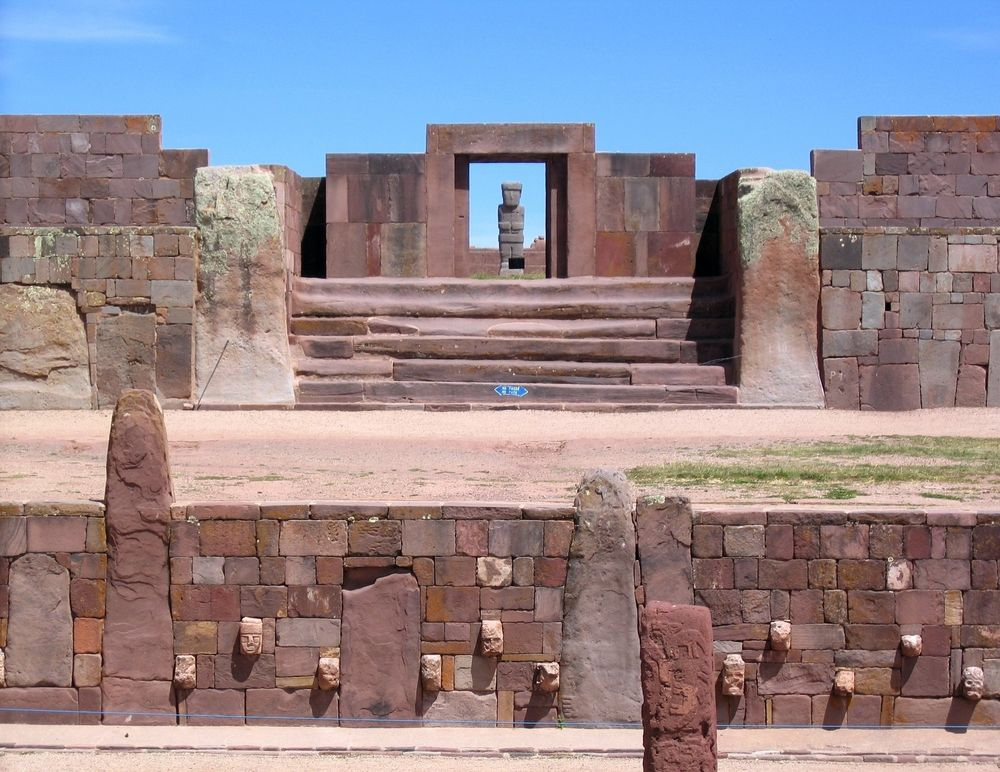If you could time travel to when the Tiwanaku civilization was at its peak, what would be your first impression upon seeing this site? Time traveling to the peak of the Tiwanaku civilization, the first impression upon seeing this site would be one of awe and wonder. The towering stone structures would appear even more majestic in their prime, their intricate carvings and precise engineering unweathered by time. The site would likely be bustling with activity, with artisans skillfully working on stone carvings, priests performing rituals, and traders engaging in lively exchanges. The vibrant colors of textiles and decorations adorning the structures would be a stark contrast against the serene backdrop of the high-altitude Andean plains. The air would be filled with the sounds of human voices, music, and the ever-present wind blowing through the surrounding landscape. The grandeur of the architecture, combined with the palpable sense of a thriving, spiritually rich society, would leave an indelible impression of a sophisticated and culturally dynamic civilization. How might the Tiwanaku people have utilized this structure in their daily lives? The Tiwanaku people likely utilized this structure for a variety of essential functions that intertwined their daily lives with their spiritual and administrative practices. This central edifice could have served as a ceremonial center, where rituals and religious ceremonies were conducted to honor their gods and seek blessings for harvests, health, and prosperity. It may have also played a role in governance, hosting important meetings of leaders and officials for political and social decision-making. The elevated staircase leading to the doorway suggests a sanctified space, potentially used by priests for rituals and as a vantage point for addressing the community. Additionally, the location and impressive architecture of the structure imply its use as a landmark for gatherings, celebrations, and possibly as a place for education and the passing on of crucial societal traditions and knowledge to the younger generations. Its multifaceted use would reflect the integrated nature of religion, politics, and community in Tiwanaku society. 